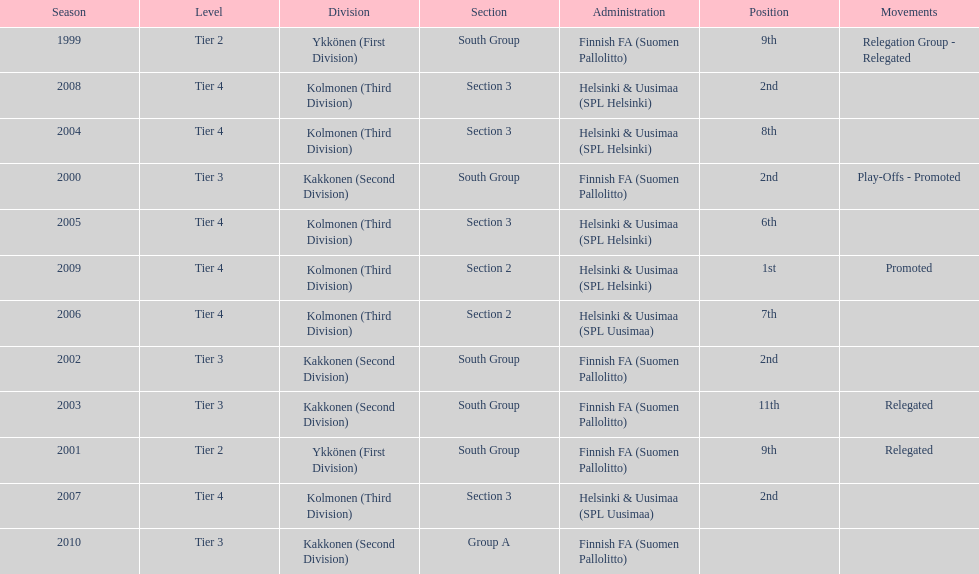How many consecutive times did they play in tier 4? 6. Help me parse the entirety of this table. {'header': ['Season', 'Level', 'Division', 'Section', 'Administration', 'Position', 'Movements'], 'rows': [['1999', 'Tier 2', 'Ykkönen (First Division)', 'South Group', 'Finnish FA (Suomen Pallolitto)', '9th', 'Relegation Group - Relegated'], ['2008', 'Tier 4', 'Kolmonen (Third Division)', 'Section 3', 'Helsinki & Uusimaa (SPL Helsinki)', '2nd', ''], ['2004', 'Tier 4', 'Kolmonen (Third Division)', 'Section 3', 'Helsinki & Uusimaa (SPL Helsinki)', '8th', ''], ['2000', 'Tier 3', 'Kakkonen (Second Division)', 'South Group', 'Finnish FA (Suomen Pallolitto)', '2nd', 'Play-Offs - Promoted'], ['2005', 'Tier 4', 'Kolmonen (Third Division)', 'Section 3', 'Helsinki & Uusimaa (SPL Helsinki)', '6th', ''], ['2009', 'Tier 4', 'Kolmonen (Third Division)', 'Section 2', 'Helsinki & Uusimaa (SPL Helsinki)', '1st', 'Promoted'], ['2006', 'Tier 4', 'Kolmonen (Third Division)', 'Section 2', 'Helsinki & Uusimaa (SPL Uusimaa)', '7th', ''], ['2002', 'Tier 3', 'Kakkonen (Second Division)', 'South Group', 'Finnish FA (Suomen Pallolitto)', '2nd', ''], ['2003', 'Tier 3', 'Kakkonen (Second Division)', 'South Group', 'Finnish FA (Suomen Pallolitto)', '11th', 'Relegated'], ['2001', 'Tier 2', 'Ykkönen (First Division)', 'South Group', 'Finnish FA (Suomen Pallolitto)', '9th', 'Relegated'], ['2007', 'Tier 4', 'Kolmonen (Third Division)', 'Section 3', 'Helsinki & Uusimaa (SPL Uusimaa)', '2nd', ''], ['2010', 'Tier 3', 'Kakkonen (Second Division)', 'Group A', 'Finnish FA (Suomen Pallolitto)', '', '']]} 